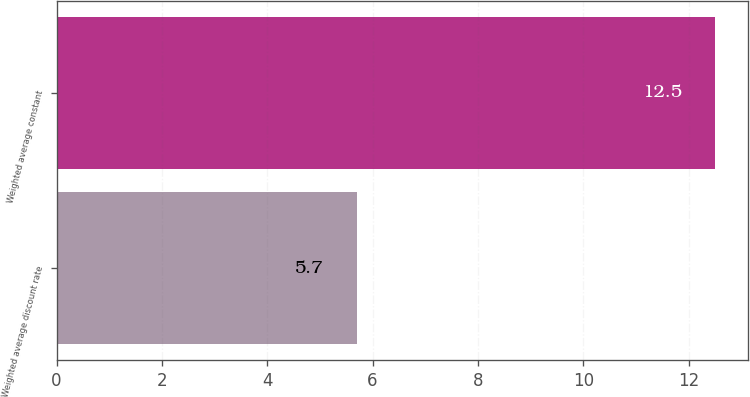<chart> <loc_0><loc_0><loc_500><loc_500><bar_chart><fcel>Weighted average discount rate<fcel>Weighted average constant<nl><fcel>5.7<fcel>12.5<nl></chart> 